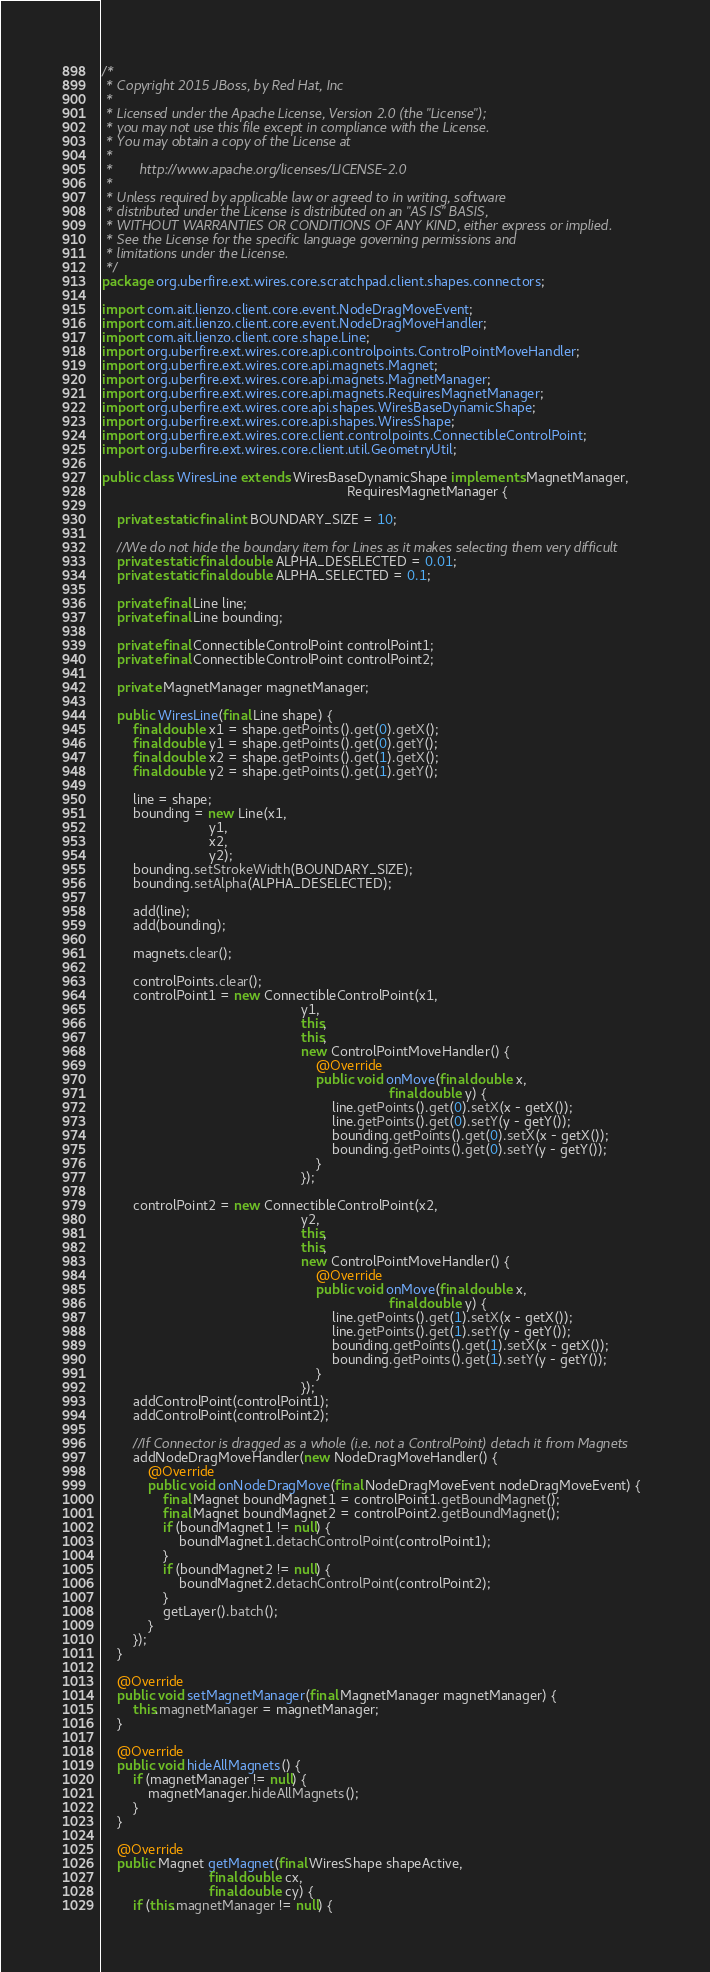Convert code to text. <code><loc_0><loc_0><loc_500><loc_500><_Java_>/*
 * Copyright 2015 JBoss, by Red Hat, Inc
 *
 * Licensed under the Apache License, Version 2.0 (the "License");
 * you may not use this file except in compliance with the License.
 * You may obtain a copy of the License at
 *
 *       http://www.apache.org/licenses/LICENSE-2.0
 *
 * Unless required by applicable law or agreed to in writing, software
 * distributed under the License is distributed on an "AS IS" BASIS,
 * WITHOUT WARRANTIES OR CONDITIONS OF ANY KIND, either express or implied.
 * See the License for the specific language governing permissions and
 * limitations under the License.
 */
package org.uberfire.ext.wires.core.scratchpad.client.shapes.connectors;

import com.ait.lienzo.client.core.event.NodeDragMoveEvent;
import com.ait.lienzo.client.core.event.NodeDragMoveHandler;
import com.ait.lienzo.client.core.shape.Line;
import org.uberfire.ext.wires.core.api.controlpoints.ControlPointMoveHandler;
import org.uberfire.ext.wires.core.api.magnets.Magnet;
import org.uberfire.ext.wires.core.api.magnets.MagnetManager;
import org.uberfire.ext.wires.core.api.magnets.RequiresMagnetManager;
import org.uberfire.ext.wires.core.api.shapes.WiresBaseDynamicShape;
import org.uberfire.ext.wires.core.api.shapes.WiresShape;
import org.uberfire.ext.wires.core.client.controlpoints.ConnectibleControlPoint;
import org.uberfire.ext.wires.core.client.util.GeometryUtil;

public class WiresLine extends WiresBaseDynamicShape implements MagnetManager,
                                                                RequiresMagnetManager {

    private static final int BOUNDARY_SIZE = 10;

    //We do not hide the boundary item for Lines as it makes selecting them very difficult
    private static final double ALPHA_DESELECTED = 0.01;
    private static final double ALPHA_SELECTED = 0.1;

    private final Line line;
    private final Line bounding;

    private final ConnectibleControlPoint controlPoint1;
    private final ConnectibleControlPoint controlPoint2;

    private MagnetManager magnetManager;

    public WiresLine(final Line shape) {
        final double x1 = shape.getPoints().get(0).getX();
        final double y1 = shape.getPoints().get(0).getY();
        final double x2 = shape.getPoints().get(1).getX();
        final double y2 = shape.getPoints().get(1).getY();

        line = shape;
        bounding = new Line(x1,
                            y1,
                            x2,
                            y2);
        bounding.setStrokeWidth(BOUNDARY_SIZE);
        bounding.setAlpha(ALPHA_DESELECTED);

        add(line);
        add(bounding);

        magnets.clear();

        controlPoints.clear();
        controlPoint1 = new ConnectibleControlPoint(x1,
                                                    y1,
                                                    this,
                                                    this,
                                                    new ControlPointMoveHandler() {
                                                        @Override
                                                        public void onMove(final double x,
                                                                           final double y) {
                                                            line.getPoints().get(0).setX(x - getX());
                                                            line.getPoints().get(0).setY(y - getY());
                                                            bounding.getPoints().get(0).setX(x - getX());
                                                            bounding.getPoints().get(0).setY(y - getY());
                                                        }
                                                    });

        controlPoint2 = new ConnectibleControlPoint(x2,
                                                    y2,
                                                    this,
                                                    this,
                                                    new ControlPointMoveHandler() {
                                                        @Override
                                                        public void onMove(final double x,
                                                                           final double y) {
                                                            line.getPoints().get(1).setX(x - getX());
                                                            line.getPoints().get(1).setY(y - getY());
                                                            bounding.getPoints().get(1).setX(x - getX());
                                                            bounding.getPoints().get(1).setY(y - getY());
                                                        }
                                                    });
        addControlPoint(controlPoint1);
        addControlPoint(controlPoint2);

        //If Connector is dragged as a whole (i.e. not a ControlPoint) detach it from Magnets
        addNodeDragMoveHandler(new NodeDragMoveHandler() {
            @Override
            public void onNodeDragMove(final NodeDragMoveEvent nodeDragMoveEvent) {
                final Magnet boundMagnet1 = controlPoint1.getBoundMagnet();
                final Magnet boundMagnet2 = controlPoint2.getBoundMagnet();
                if (boundMagnet1 != null) {
                    boundMagnet1.detachControlPoint(controlPoint1);
                }
                if (boundMagnet2 != null) {
                    boundMagnet2.detachControlPoint(controlPoint2);
                }
                getLayer().batch();
            }
        });
    }

    @Override
    public void setMagnetManager(final MagnetManager magnetManager) {
        this.magnetManager = magnetManager;
    }

    @Override
    public void hideAllMagnets() {
        if (magnetManager != null) {
            magnetManager.hideAllMagnets();
        }
    }

    @Override
    public Magnet getMagnet(final WiresShape shapeActive,
                            final double cx,
                            final double cy) {
        if (this.magnetManager != null) {</code> 